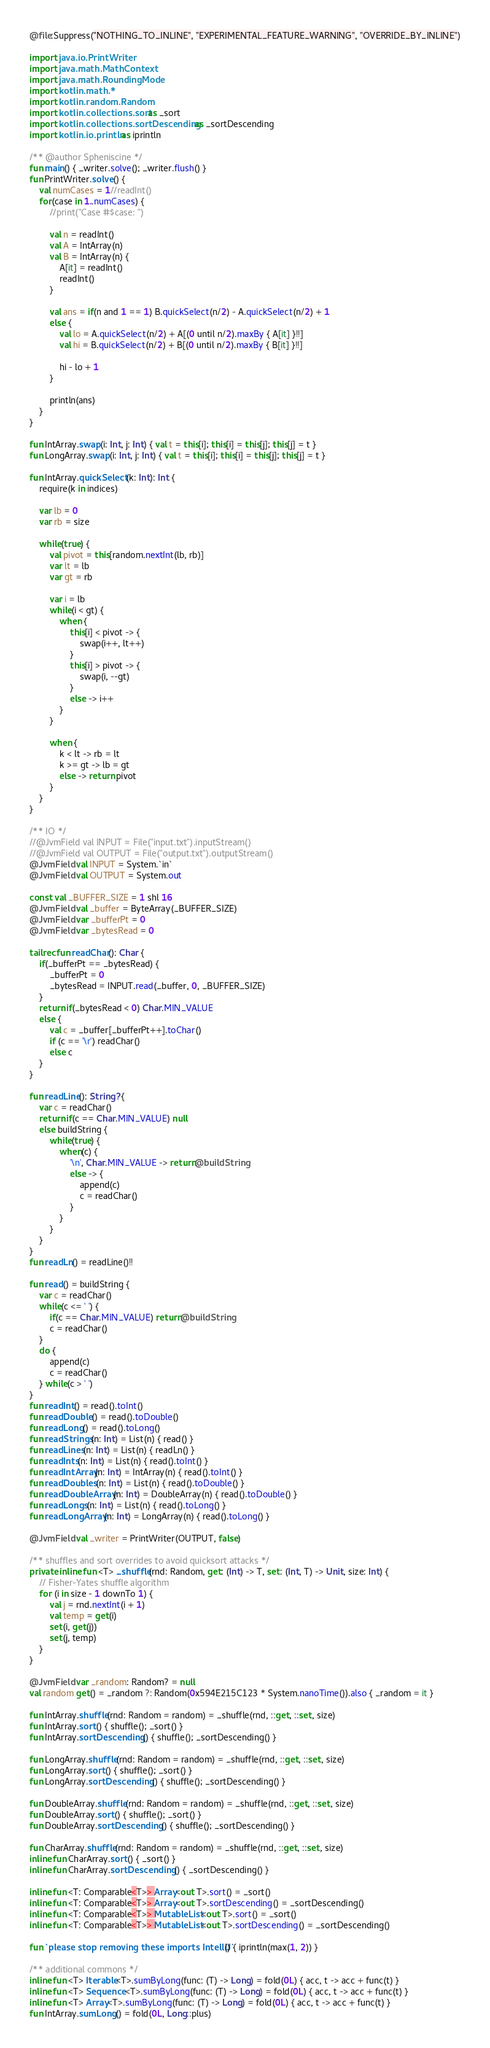Convert code to text. <code><loc_0><loc_0><loc_500><loc_500><_Kotlin_>@file:Suppress("NOTHING_TO_INLINE", "EXPERIMENTAL_FEATURE_WARNING", "OVERRIDE_BY_INLINE")

import java.io.PrintWriter
import java.math.MathContext
import java.math.RoundingMode
import kotlin.math.*
import kotlin.random.Random
import kotlin.collections.sort as _sort
import kotlin.collections.sortDescending as _sortDescending
import kotlin.io.println as iprintln

/** @author Spheniscine */
fun main() { _writer.solve(); _writer.flush() }
fun PrintWriter.solve() {
    val numCases = 1//readInt()
    for(case in 1..numCases) {
        //print("Case #$case: ")

        val n = readInt()
        val A = IntArray(n)
        val B = IntArray(n) {
            A[it] = readInt()
            readInt()
        }

        val ans = if(n and 1 == 1) B.quickSelect(n/2) - A.quickSelect(n/2) + 1
        else {
            val lo = A.quickSelect(n/2) + A[(0 until n/2).maxBy { A[it] }!!]
            val hi = B.quickSelect(n/2) + B[(0 until n/2).maxBy { B[it] }!!]

            hi - lo + 1
        }

        println(ans)
    }
}

fun IntArray.swap(i: Int, j: Int) { val t = this[i]; this[i] = this[j]; this[j] = t }
fun LongArray.swap(i: Int, j: Int) { val t = this[i]; this[i] = this[j]; this[j] = t }

fun IntArray.quickSelect(k: Int): Int {
    require(k in indices)

    var lb = 0
    var rb = size

    while(true) {
        val pivot = this[random.nextInt(lb, rb)]
        var lt = lb
        var gt = rb

        var i = lb
        while(i < gt) {
            when {
                this[i] < pivot -> {
                    swap(i++, lt++)
                }
                this[i] > pivot -> {
                    swap(i, --gt)
                }
                else -> i++
            }
        }

        when {
            k < lt -> rb = lt
            k >= gt -> lb = gt
            else -> return pivot
        }
    }
}

/** IO */
//@JvmField val INPUT = File("input.txt").inputStream()
//@JvmField val OUTPUT = File("output.txt").outputStream()
@JvmField val INPUT = System.`in`
@JvmField val OUTPUT = System.out

const val _BUFFER_SIZE = 1 shl 16
@JvmField val _buffer = ByteArray(_BUFFER_SIZE)
@JvmField var _bufferPt = 0
@JvmField var _bytesRead = 0

tailrec fun readChar(): Char {
    if(_bufferPt == _bytesRead) {
        _bufferPt = 0
        _bytesRead = INPUT.read(_buffer, 0, _BUFFER_SIZE)
    }
    return if(_bytesRead < 0) Char.MIN_VALUE
    else {
        val c = _buffer[_bufferPt++].toChar()
        if (c == '\r') readChar()
        else c
    }
}

fun readLine(): String? {
    var c = readChar()
    return if(c == Char.MIN_VALUE) null
    else buildString {
        while(true) {
            when(c) {
                '\n', Char.MIN_VALUE -> return@buildString
                else -> {
                    append(c)
                    c = readChar()
                }
            }
        }
    }
}
fun readLn() = readLine()!!

fun read() = buildString {
    var c = readChar()
    while(c <= ' ') {
        if(c == Char.MIN_VALUE) return@buildString
        c = readChar()
    }
    do {
        append(c)
        c = readChar()
    } while(c > ' ')
}
fun readInt() = read().toInt()
fun readDouble() = read().toDouble()
fun readLong() = read().toLong()
fun readStrings(n: Int) = List(n) { read() }
fun readLines(n: Int) = List(n) { readLn() }
fun readInts(n: Int) = List(n) { read().toInt() }
fun readIntArray(n: Int) = IntArray(n) { read().toInt() }
fun readDoubles(n: Int) = List(n) { read().toDouble() }
fun readDoubleArray(n: Int) = DoubleArray(n) { read().toDouble() }
fun readLongs(n: Int) = List(n) { read().toLong() }
fun readLongArray(n: Int) = LongArray(n) { read().toLong() }

@JvmField val _writer = PrintWriter(OUTPUT, false)

/** shuffles and sort overrides to avoid quicksort attacks */
private inline fun <T> _shuffle(rnd: Random, get: (Int) -> T, set: (Int, T) -> Unit, size: Int) {
    // Fisher-Yates shuffle algorithm
    for (i in size - 1 downTo 1) {
        val j = rnd.nextInt(i + 1)
        val temp = get(i)
        set(i, get(j))
        set(j, temp)
    }
}

@JvmField var _random: Random? = null
val random get() = _random ?: Random(0x594E215C123 * System.nanoTime()).also { _random = it }

fun IntArray.shuffle(rnd: Random = random) = _shuffle(rnd, ::get, ::set, size)
fun IntArray.sort() { shuffle(); _sort() }
fun IntArray.sortDescending() { shuffle(); _sortDescending() }

fun LongArray.shuffle(rnd: Random = random) = _shuffle(rnd, ::get, ::set, size)
fun LongArray.sort() { shuffle(); _sort() }
fun LongArray.sortDescending() { shuffle(); _sortDescending() }

fun DoubleArray.shuffle(rnd: Random = random) = _shuffle(rnd, ::get, ::set, size)
fun DoubleArray.sort() { shuffle(); _sort() }
fun DoubleArray.sortDescending() { shuffle(); _sortDescending() }

fun CharArray.shuffle(rnd: Random = random) = _shuffle(rnd, ::get, ::set, size)
inline fun CharArray.sort() { _sort() }
inline fun CharArray.sortDescending() { _sortDescending() }

inline fun <T: Comparable<T>> Array<out T>.sort() = _sort()
inline fun <T: Comparable<T>> Array<out T>.sortDescending() = _sortDescending()
inline fun <T: Comparable<T>> MutableList<out T>.sort() = _sort()
inline fun <T: Comparable<T>> MutableList<out T>.sortDescending() = _sortDescending()

fun `please stop removing these imports IntelliJ`() { iprintln(max(1, 2)) }

/** additional commons */
inline fun <T> Iterable<T>.sumByLong(func: (T) -> Long) = fold(0L) { acc, t -> acc + func(t) }
inline fun <T> Sequence<T>.sumByLong(func: (T) -> Long) = fold(0L) { acc, t -> acc + func(t) }
inline fun <T> Array<T>.sumByLong(func: (T) -> Long) = fold(0L) { acc, t -> acc + func(t) }
fun IntArray.sumLong() = fold(0L, Long::plus)
</code> 